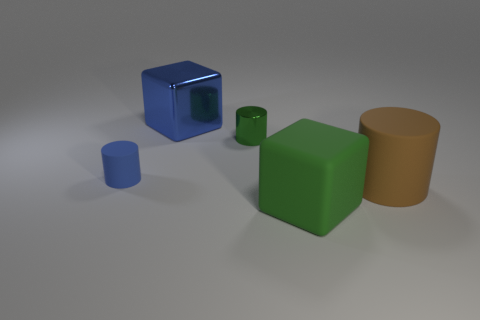Is the large metal object the same color as the tiny rubber cylinder?
Offer a terse response. Yes. There is a block right of the cube that is behind the large green block; are there any matte cylinders to the left of it?
Ensure brevity in your answer.  Yes. What number of rubber objects are cylinders or green spheres?
Give a very brief answer. 2. How many other things are there of the same shape as the big green matte object?
Your response must be concise. 1. Is the number of metallic cubes greater than the number of blue balls?
Keep it short and to the point. Yes. There is a rubber cylinder on the right side of the large cube in front of the tiny blue matte cylinder that is left of the big blue thing; how big is it?
Your answer should be very brief. Large. There is a metallic thing to the right of the blue block; what is its size?
Your answer should be compact. Small. What number of objects are either green matte cylinders or tiny cylinders that are behind the small blue cylinder?
Give a very brief answer. 1. How many other things are there of the same size as the green matte block?
Offer a terse response. 2. What is the material of the small green object that is the same shape as the small blue object?
Your answer should be compact. Metal. 